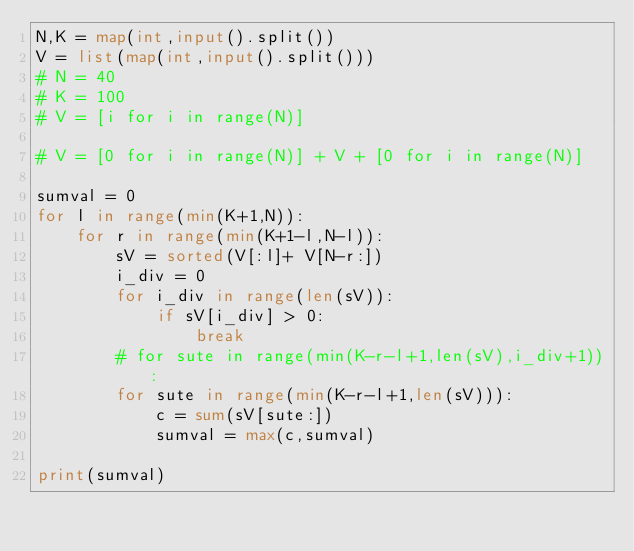<code> <loc_0><loc_0><loc_500><loc_500><_Python_>N,K = map(int,input().split())
V = list(map(int,input().split()))
# N = 40
# K = 100
# V = [i for i in range(N)]

# V = [0 for i in range(N)] + V + [0 for i in range(N)] 

sumval = 0
for l in range(min(K+1,N)):
    for r in range(min(K+1-l,N-l)):
        sV = sorted(V[:l]+ V[N-r:])
        i_div = 0
        for i_div in range(len(sV)):
            if sV[i_div] > 0:
                break
        # for sute in range(min(K-r-l+1,len(sV),i_div+1)):
        for sute in range(min(K-r-l+1,len(sV))):
            c = sum(sV[sute:])
            sumval = max(c,sumval)

print(sumval)</code> 